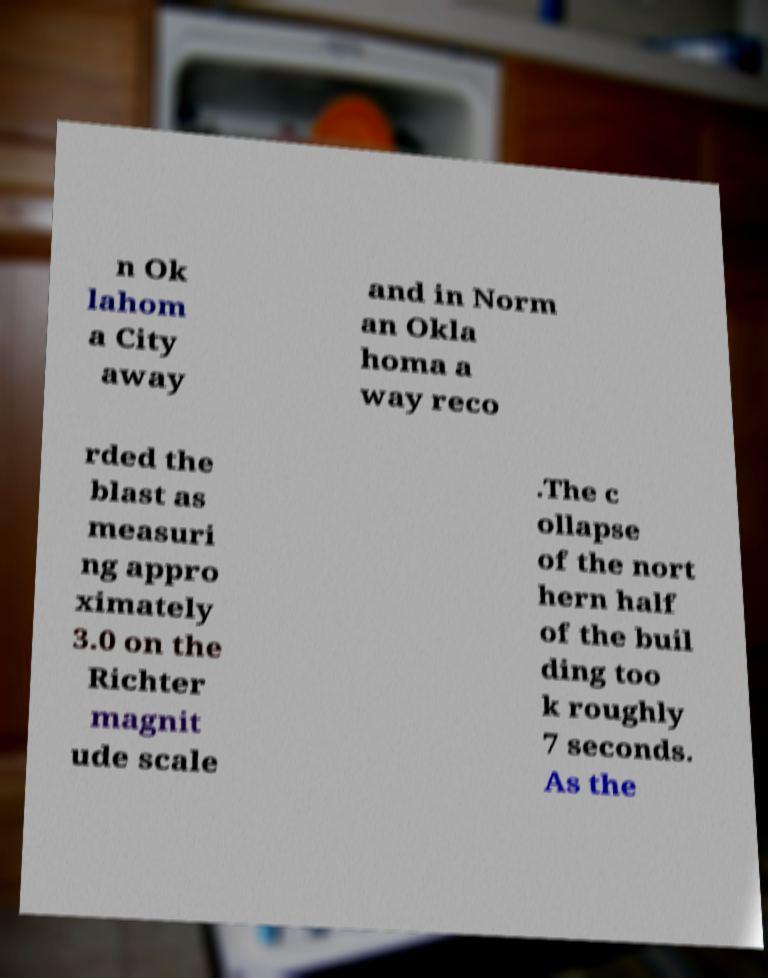Can you accurately transcribe the text from the provided image for me? n Ok lahom a City away and in Norm an Okla homa a way reco rded the blast as measuri ng appro ximately 3.0 on the Richter magnit ude scale .The c ollapse of the nort hern half of the buil ding too k roughly 7 seconds. As the 